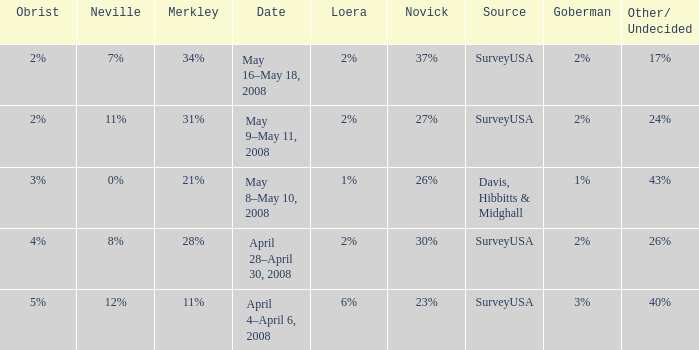Which Neville has a Novick of 23%? 12%. 